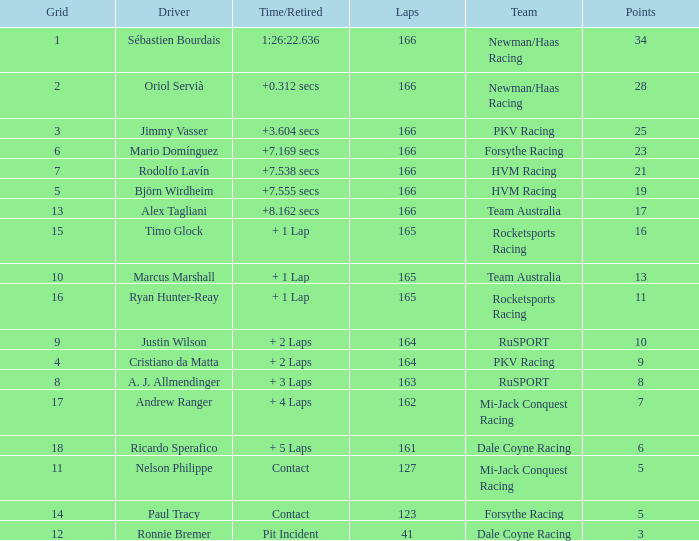What is the average points that the driver Ryan Hunter-Reay has? 11.0. 